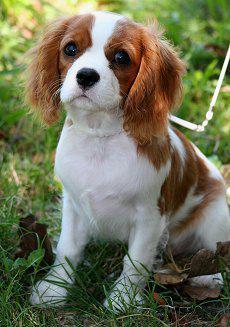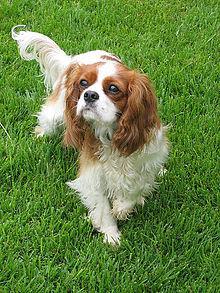The first image is the image on the left, the second image is the image on the right. Considering the images on both sides, is "One image depicts exactly two dogs side by side on grass." valid? Answer yes or no. No. 